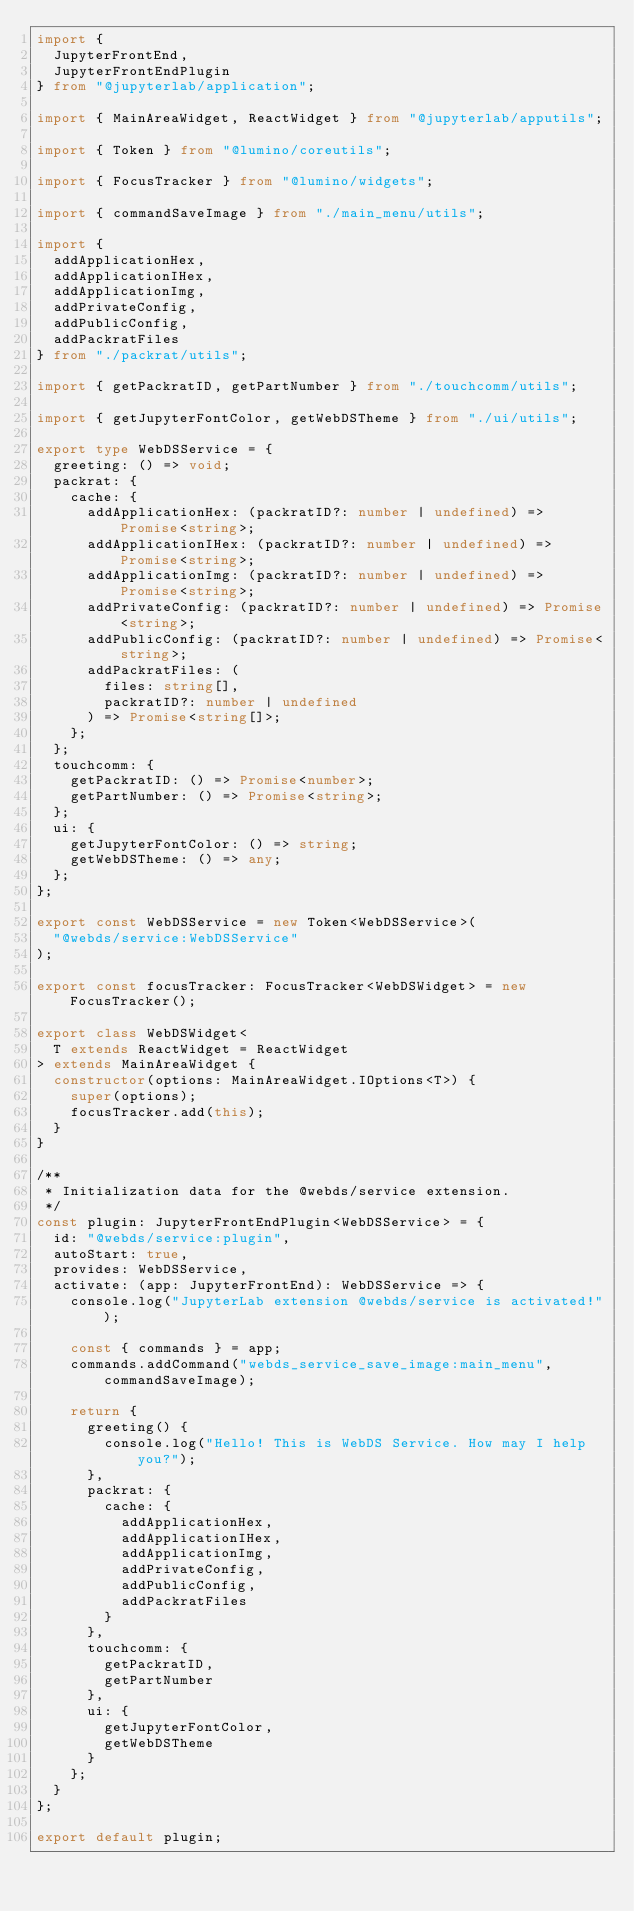<code> <loc_0><loc_0><loc_500><loc_500><_TypeScript_>import {
  JupyterFrontEnd,
  JupyterFrontEndPlugin
} from "@jupyterlab/application";

import { MainAreaWidget, ReactWidget } from "@jupyterlab/apputils";

import { Token } from "@lumino/coreutils";

import { FocusTracker } from "@lumino/widgets";

import { commandSaveImage } from "./main_menu/utils";

import {
  addApplicationHex,
  addApplicationIHex,
  addApplicationImg,
  addPrivateConfig,
  addPublicConfig,
  addPackratFiles
} from "./packrat/utils";

import { getPackratID, getPartNumber } from "./touchcomm/utils";

import { getJupyterFontColor, getWebDSTheme } from "./ui/utils";

export type WebDSService = {
  greeting: () => void;
  packrat: {
    cache: {
      addApplicationHex: (packratID?: number | undefined) => Promise<string>;
      addApplicationIHex: (packratID?: number | undefined) => Promise<string>;
      addApplicationImg: (packratID?: number | undefined) => Promise<string>;
      addPrivateConfig: (packratID?: number | undefined) => Promise<string>;
      addPublicConfig: (packratID?: number | undefined) => Promise<string>;
      addPackratFiles: (
        files: string[],
        packratID?: number | undefined
      ) => Promise<string[]>;
    };
  };
  touchcomm: {
    getPackratID: () => Promise<number>;
    getPartNumber: () => Promise<string>;
  };
  ui: {
    getJupyterFontColor: () => string;
    getWebDSTheme: () => any;
  };
};

export const WebDSService = new Token<WebDSService>(
  "@webds/service:WebDSService"
);

export const focusTracker: FocusTracker<WebDSWidget> = new FocusTracker();

export class WebDSWidget<
  T extends ReactWidget = ReactWidget
> extends MainAreaWidget {
  constructor(options: MainAreaWidget.IOptions<T>) {
    super(options);
    focusTracker.add(this);
  }
}

/**
 * Initialization data for the @webds/service extension.
 */
const plugin: JupyterFrontEndPlugin<WebDSService> = {
  id: "@webds/service:plugin",
  autoStart: true,
  provides: WebDSService,
  activate: (app: JupyterFrontEnd): WebDSService => {
    console.log("JupyterLab extension @webds/service is activated!");

    const { commands } = app;
    commands.addCommand("webds_service_save_image:main_menu", commandSaveImage);

    return {
      greeting() {
        console.log("Hello! This is WebDS Service. How may I help you?");
      },
      packrat: {
        cache: {
          addApplicationHex,
          addApplicationIHex,
          addApplicationImg,
          addPrivateConfig,
          addPublicConfig,
          addPackratFiles
        }
      },
      touchcomm: {
        getPackratID,
        getPartNumber
      },
      ui: {
        getJupyterFontColor,
        getWebDSTheme
      }
    };
  }
};

export default plugin;
</code> 